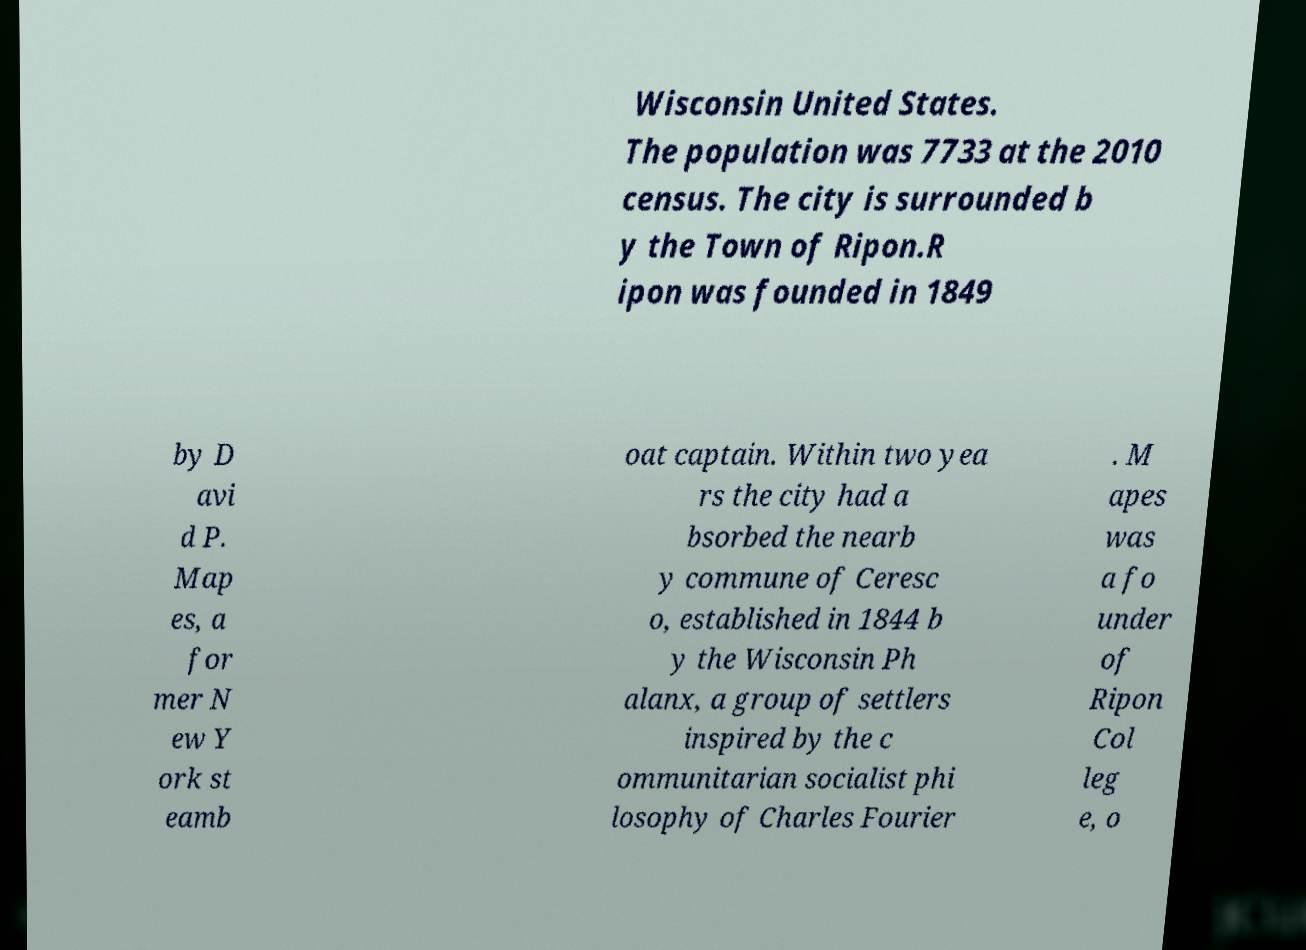Could you assist in decoding the text presented in this image and type it out clearly? Wisconsin United States. The population was 7733 at the 2010 census. The city is surrounded b y the Town of Ripon.R ipon was founded in 1849 by D avi d P. Map es, a for mer N ew Y ork st eamb oat captain. Within two yea rs the city had a bsorbed the nearb y commune of Ceresc o, established in 1844 b y the Wisconsin Ph alanx, a group of settlers inspired by the c ommunitarian socialist phi losophy of Charles Fourier . M apes was a fo under of Ripon Col leg e, o 